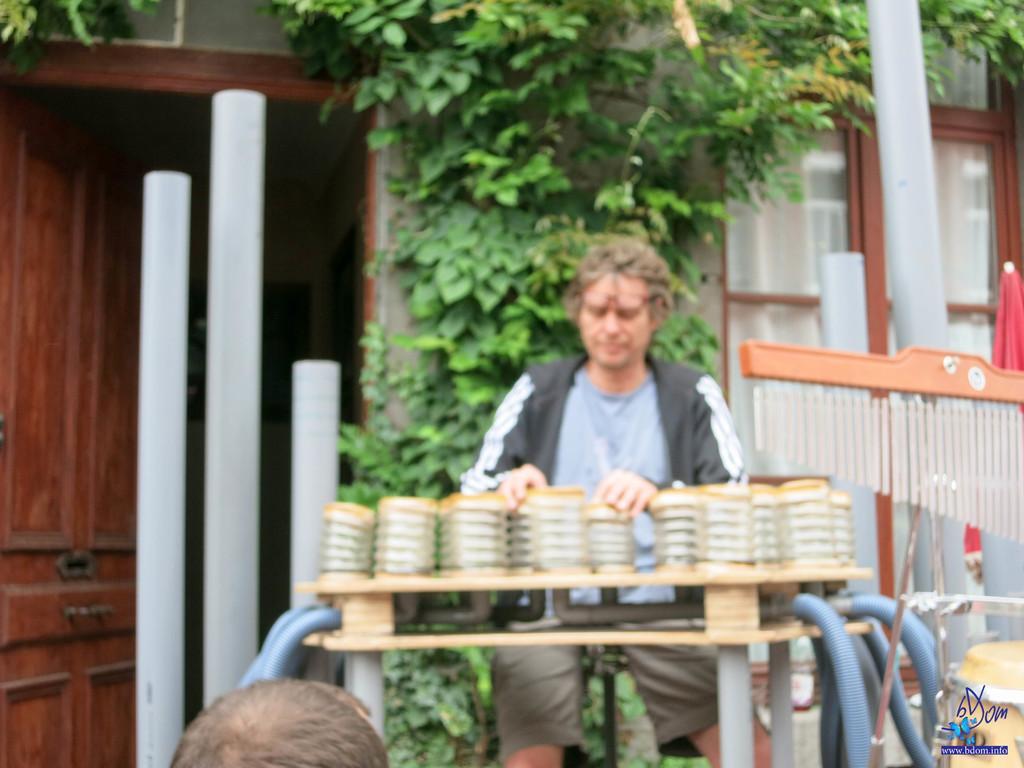Please provide a concise description of this image. In this picture there is a person who is sitting in front of the wooden table on the chair, his fixing some containers with his hands, there is a door at the left side of the image and they are plastic rods at the left side of the image, there is a tree behind the man. 